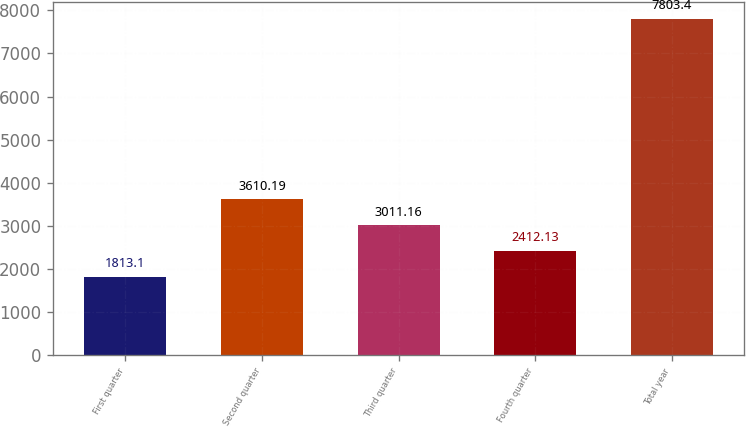Convert chart to OTSL. <chart><loc_0><loc_0><loc_500><loc_500><bar_chart><fcel>First quarter<fcel>Second quarter<fcel>Third quarter<fcel>Fourth quarter<fcel>Total year<nl><fcel>1813.1<fcel>3610.19<fcel>3011.16<fcel>2412.13<fcel>7803.4<nl></chart> 